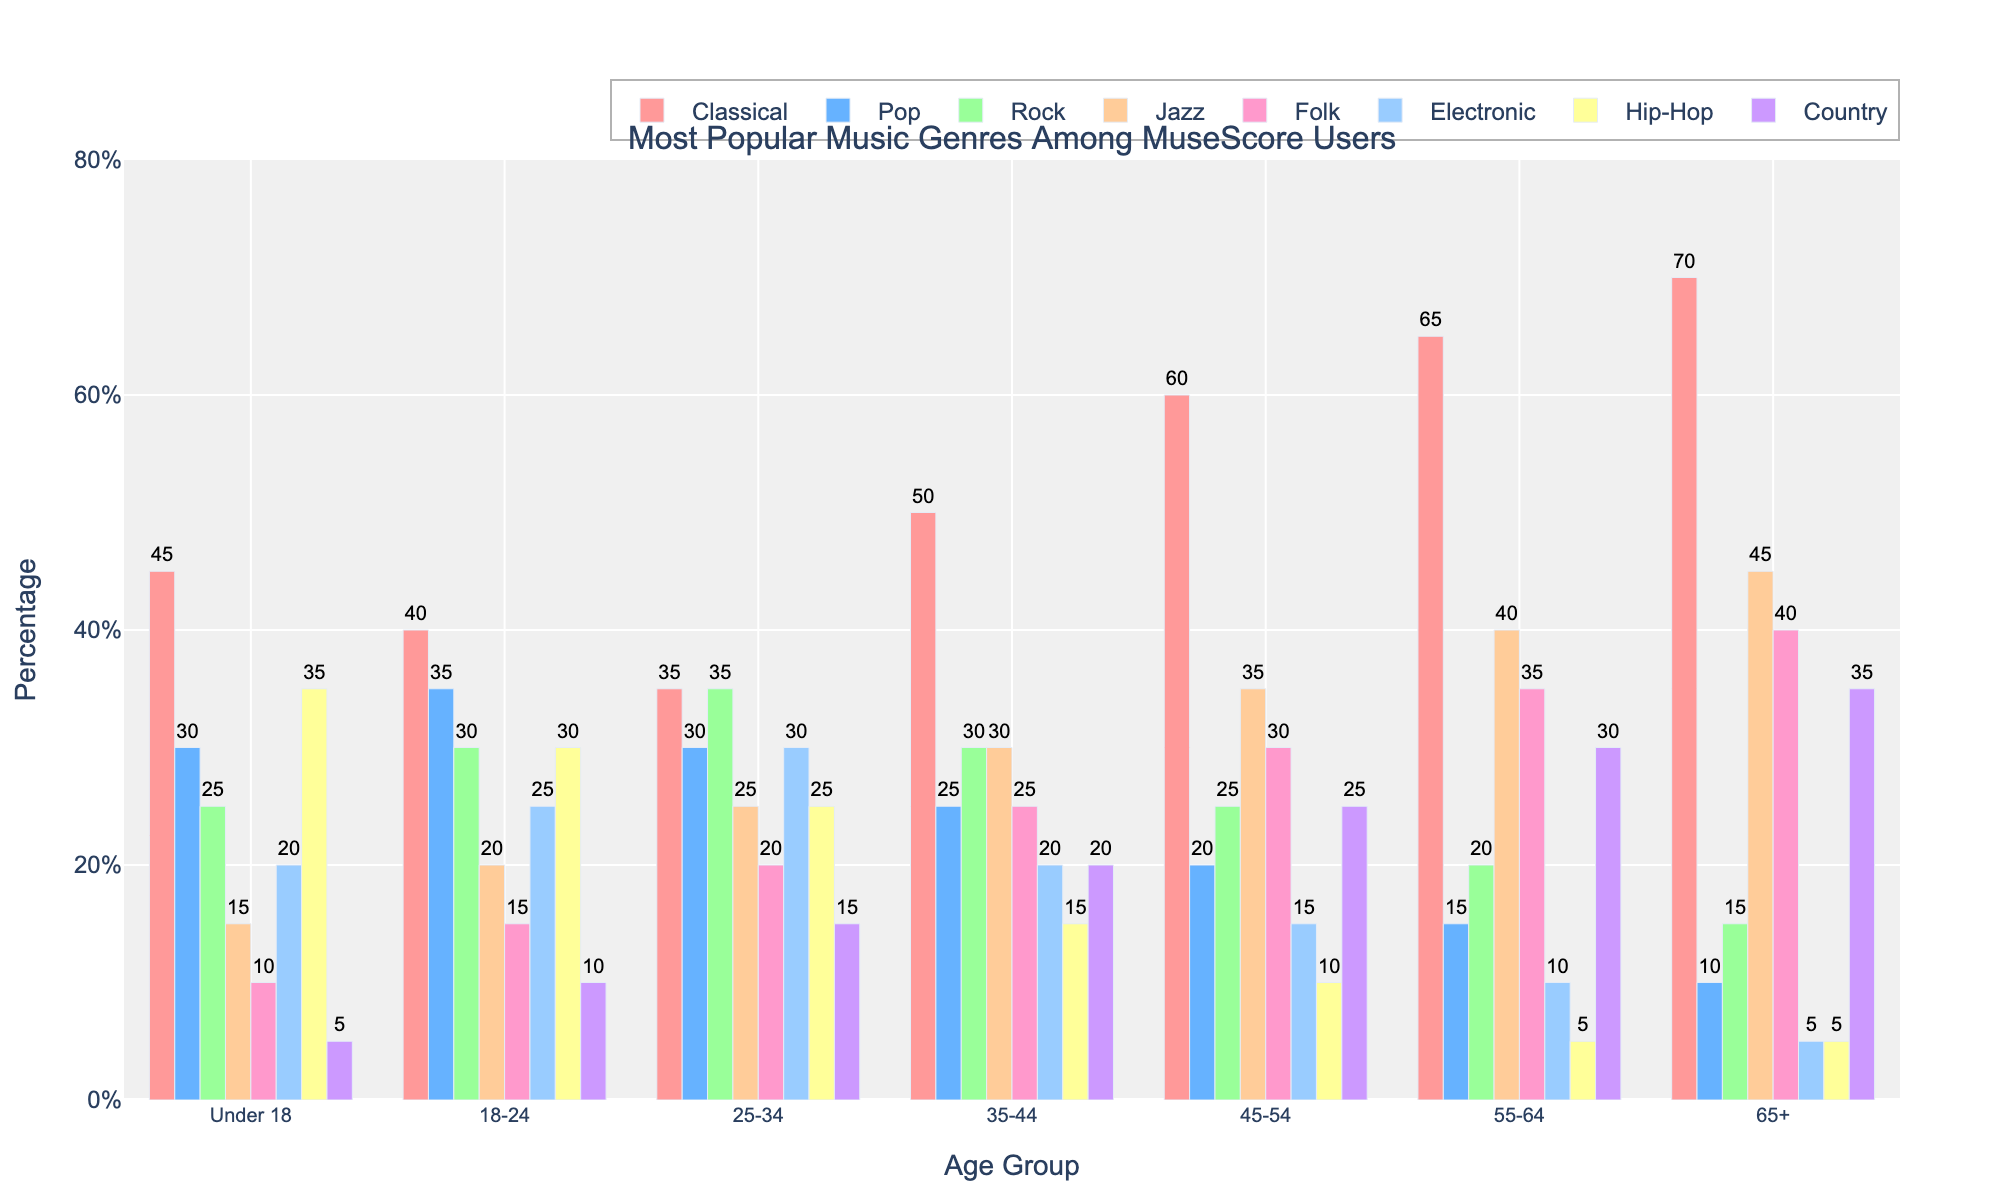What's the most popular music genre among MuseScore users aged 18-24? The height of the bars for the age group 18-24 indicates the popularity of each genre. The highest bar belongs to the Pop genre with a percentage of 35%.
Answer: Pop How many percentage points is Classical more popular than Electronic in the 55-64 age group? For the 55-64 age group, the Classical genre is at 65% and the Electronic genre is at 10%. The difference in percentage points is 65% - 10% = 55%.
Answer: 55 Which age group listens to Jazz the most? The tallest bar for the Jazz genre corresponds to the age group 65+, which is at 45%.
Answer: 65+ What's the total percentage of users aged 25-34 listening to Classical, Pop, and Rock combined? Sum the percentages for Classical, Pop, and Rock in age group 25-34: 35% + 30% + 35% = 100%.
Answer: 100 What's the median popularity of Folk music across all age groups? Arrange the percentages for Folk music in ascending order: 10, 15, 20, 25, 30, 35, 40. The median value, being the middle number, is 25%.
Answer: 25 Which genre shows a consistent decrease in popularity as the age group increases, and by how much does it decrease from Under 18 to 65+? Examine each genre's trend by comparing their heights across age groups. Hip-Hop shows a decrease: Under 18, 35%; 65+, 5% for a decrease of 35% - 5% = 30%.
Answer: Hip-Hop, 30 In the 45-54 age group, which genre has the same percentage as Pop in the 65+ age group? Compare the values for the 45-54 age group. Pop in the 65+ age group is 10%, and Electronic in the 45-54 age group also has 10%.
Answer: Electronic What's the average popularity of Country music across all age groups? Calculate the sum of Country music percentages across all age groups and then divide by the number of age groups. (5 + 10 + 15 + 20 + 25 + 30 + 35) / 7 = 140 / 7 = 20%.
Answer: 20 In which age group is Folk music more popular than Rock music, and by how much? Compare Folk and Rock values within each age group. For age 65+, Folk is 40% and Rock is 15%, yielding a difference of 40% - 15% = 25%.
Answer: 65+, 25 Which genre is the least popular among users aged Under 18? The shortest bar for the Under 18 age group represents the Country genre at 5%.
Answer: Country 